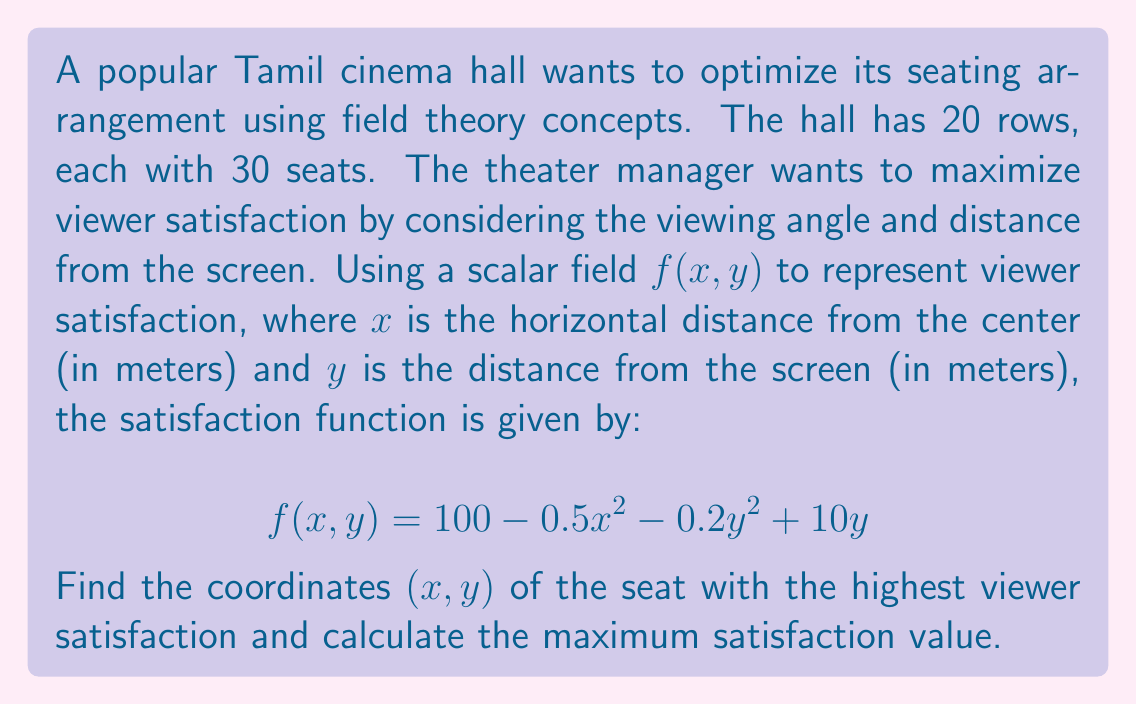Give your solution to this math problem. To find the optimal seating position, we need to locate the maximum point of the scalar field $f(x,y)$. This can be done by following these steps:

1. Calculate the partial derivatives of $f(x,y)$ with respect to $x$ and $y$:
   $$\frac{\partial f}{\partial x} = -x$$
   $$\frac{\partial f}{\partial y} = -0.4y + 10$$

2. Set both partial derivatives to zero to find the critical points:
   $$-x = 0 \implies x = 0$$
   $$-0.4y + 10 = 0 \implies y = 25$$

3. The critical point $(0, 25)$ represents the seat with the highest viewer satisfaction.

4. To confirm this is a maximum, we can check the second partial derivatives:
   $$\frac{\partial^2 f}{\partial x^2} = -1$$
   $$\frac{\partial^2 f}{\partial y^2} = -0.4$$
   
   Since both are negative, the critical point is indeed a maximum.

5. Calculate the maximum satisfaction value by plugging the coordinates into the original function:
   $$f(0, 25) = 100 - 0.5(0)^2 - 0.2(25)^2 + 10(25)$$
   $$f(0, 25) = 100 - 0 - 125 + 250 = 225$$

Therefore, the optimal seat is located at the center of the hall, 25 meters from the screen, with a maximum satisfaction value of 225.
Answer: $(0, 25)$; 225 